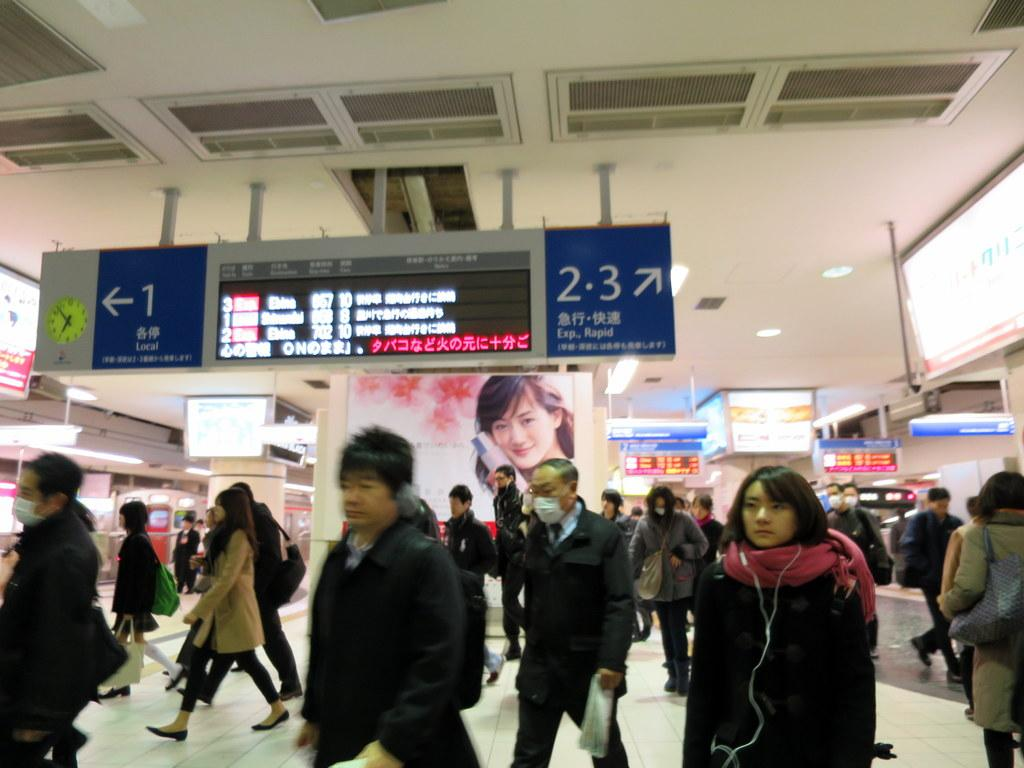How many people are in the image? There is a group of people in the image. What are the people doing in the image? The people are walking. Can you describe the clothing of the people in the image? The people are wearing different color dresses. What other objects can be seen in the image besides the people? There are boards, lights, a clock, a screen, and other objects around. What type of cactus can be seen growing near the people in the image? There is no cactus present in the image. What nut is being used to create a rhythm for the people walking in the image? There is no nut or rhythm present in the image; the people are simply walking. 